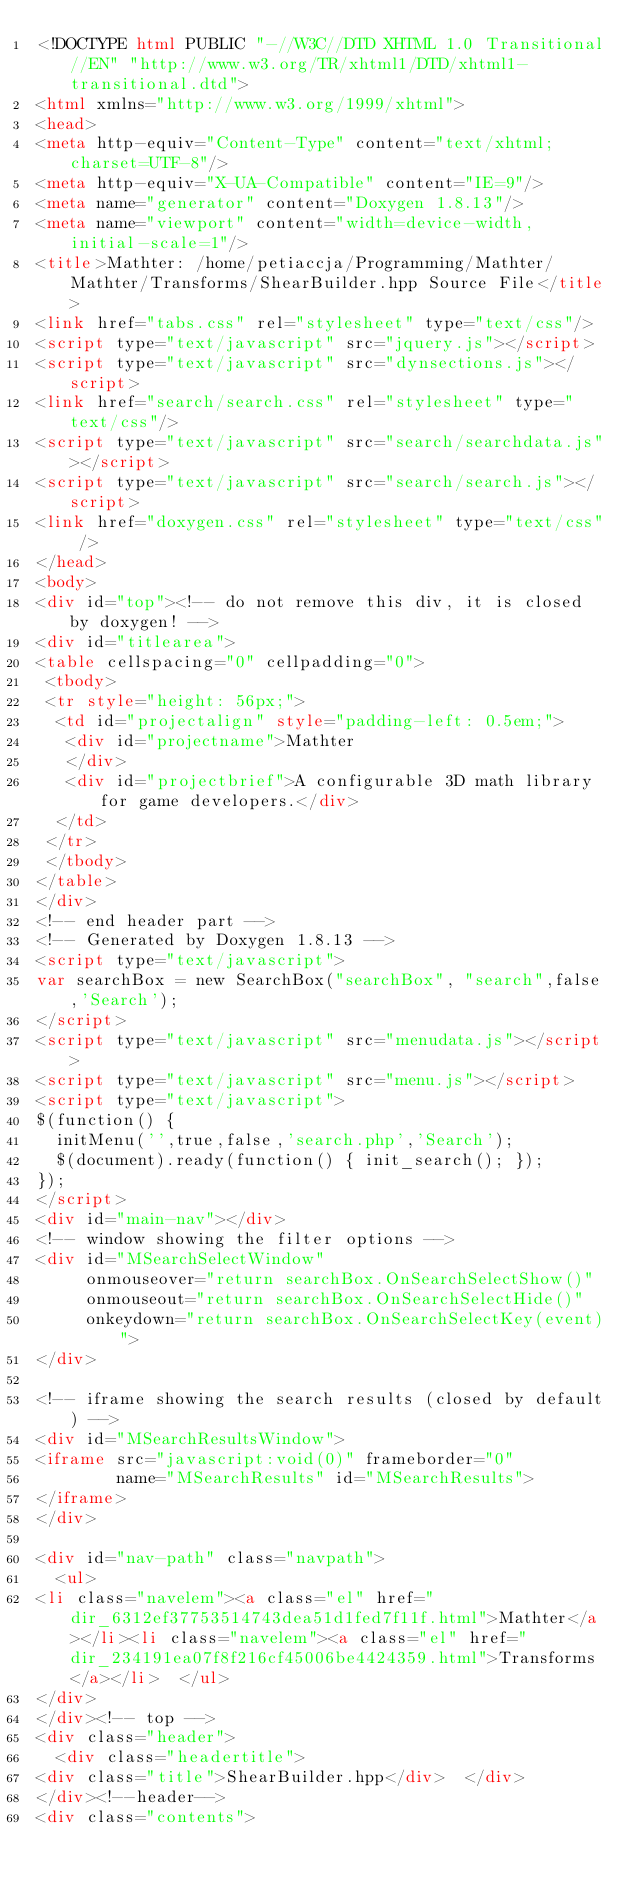<code> <loc_0><loc_0><loc_500><loc_500><_HTML_><!DOCTYPE html PUBLIC "-//W3C//DTD XHTML 1.0 Transitional//EN" "http://www.w3.org/TR/xhtml1/DTD/xhtml1-transitional.dtd">
<html xmlns="http://www.w3.org/1999/xhtml">
<head>
<meta http-equiv="Content-Type" content="text/xhtml;charset=UTF-8"/>
<meta http-equiv="X-UA-Compatible" content="IE=9"/>
<meta name="generator" content="Doxygen 1.8.13"/>
<meta name="viewport" content="width=device-width, initial-scale=1"/>
<title>Mathter: /home/petiaccja/Programming/Mathter/Mathter/Transforms/ShearBuilder.hpp Source File</title>
<link href="tabs.css" rel="stylesheet" type="text/css"/>
<script type="text/javascript" src="jquery.js"></script>
<script type="text/javascript" src="dynsections.js"></script>
<link href="search/search.css" rel="stylesheet" type="text/css"/>
<script type="text/javascript" src="search/searchdata.js"></script>
<script type="text/javascript" src="search/search.js"></script>
<link href="doxygen.css" rel="stylesheet" type="text/css" />
</head>
<body>
<div id="top"><!-- do not remove this div, it is closed by doxygen! -->
<div id="titlearea">
<table cellspacing="0" cellpadding="0">
 <tbody>
 <tr style="height: 56px;">
  <td id="projectalign" style="padding-left: 0.5em;">
   <div id="projectname">Mathter
   </div>
   <div id="projectbrief">A configurable 3D math library for game developers.</div>
  </td>
 </tr>
 </tbody>
</table>
</div>
<!-- end header part -->
<!-- Generated by Doxygen 1.8.13 -->
<script type="text/javascript">
var searchBox = new SearchBox("searchBox", "search",false,'Search');
</script>
<script type="text/javascript" src="menudata.js"></script>
<script type="text/javascript" src="menu.js"></script>
<script type="text/javascript">
$(function() {
  initMenu('',true,false,'search.php','Search');
  $(document).ready(function() { init_search(); });
});
</script>
<div id="main-nav"></div>
<!-- window showing the filter options -->
<div id="MSearchSelectWindow"
     onmouseover="return searchBox.OnSearchSelectShow()"
     onmouseout="return searchBox.OnSearchSelectHide()"
     onkeydown="return searchBox.OnSearchSelectKey(event)">
</div>

<!-- iframe showing the search results (closed by default) -->
<div id="MSearchResultsWindow">
<iframe src="javascript:void(0)" frameborder="0" 
        name="MSearchResults" id="MSearchResults">
</iframe>
</div>

<div id="nav-path" class="navpath">
  <ul>
<li class="navelem"><a class="el" href="dir_6312ef37753514743dea51d1fed7f11f.html">Mathter</a></li><li class="navelem"><a class="el" href="dir_234191ea07f8f216cf45006be4424359.html">Transforms</a></li>  </ul>
</div>
</div><!-- top -->
<div class="header">
  <div class="headertitle">
<div class="title">ShearBuilder.hpp</div>  </div>
</div><!--header-->
<div class="contents"></code> 